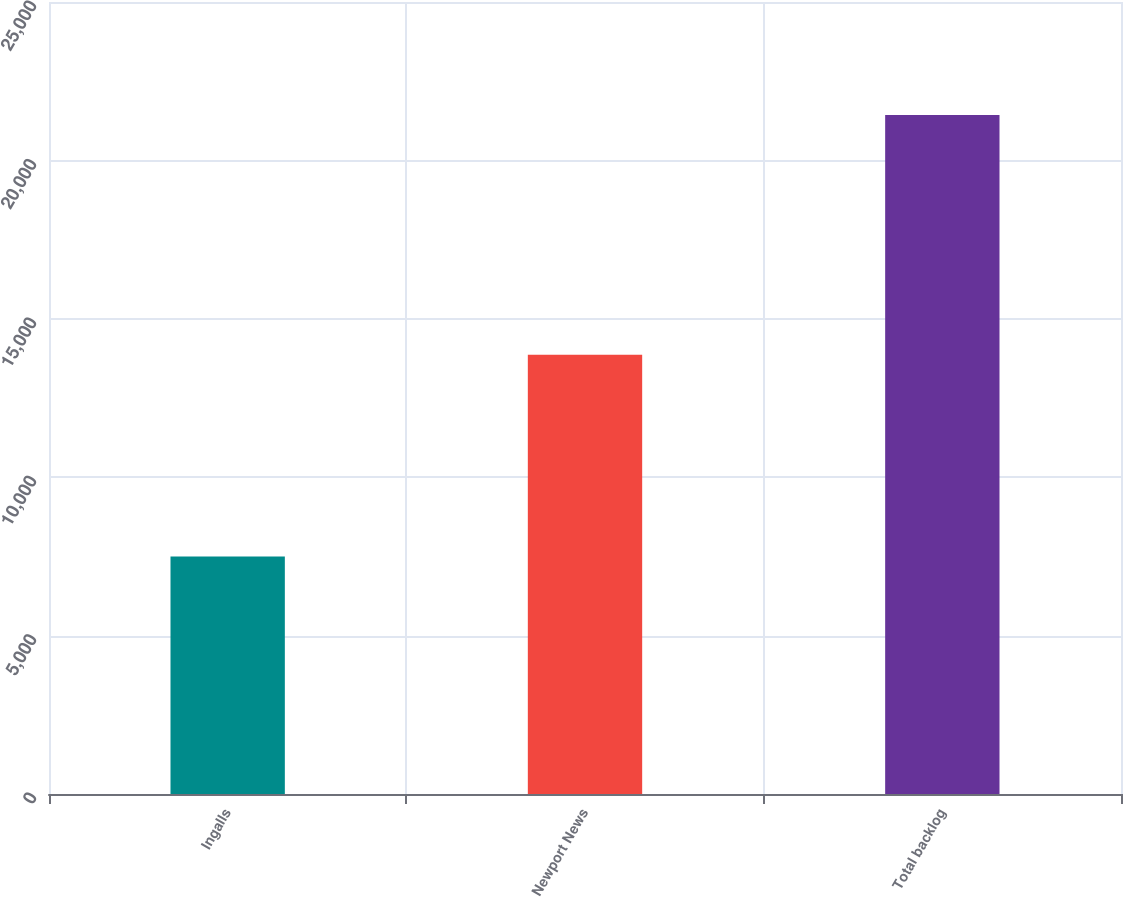Convert chart. <chart><loc_0><loc_0><loc_500><loc_500><bar_chart><fcel>Ingalls<fcel>Newport News<fcel>Total backlog<nl><fcel>7498<fcel>13867<fcel>21430<nl></chart> 